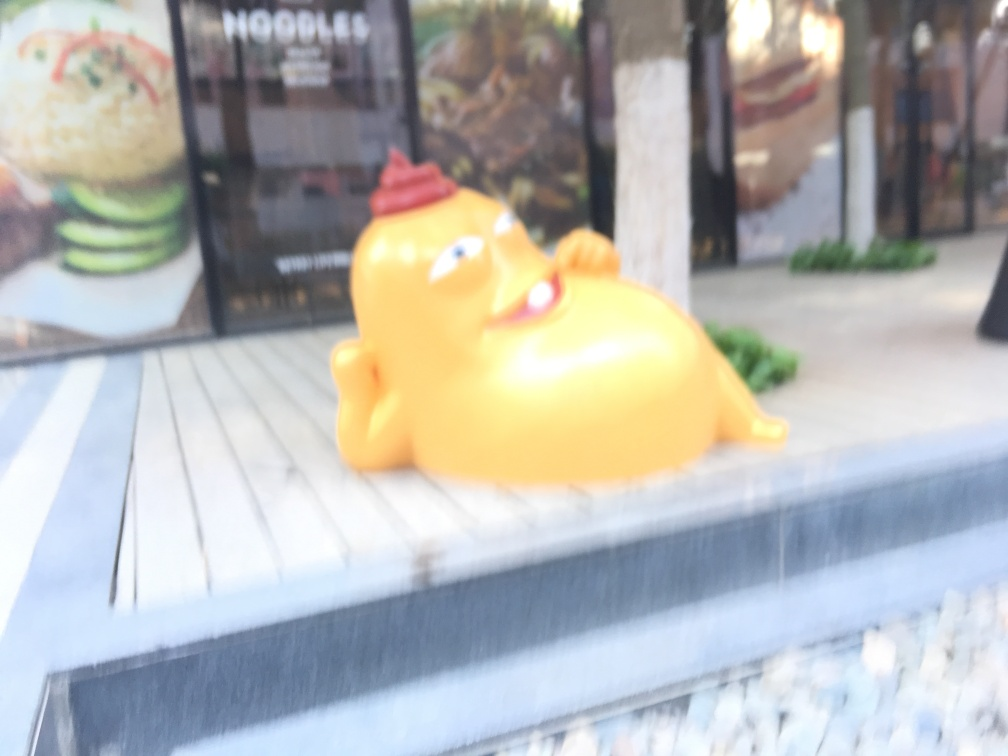What is the object in the foreground and what might it represent? The object in the foreground appears to be a stylized yellow figurine, possibly a rubber duck or a similar toy. Its exaggerated features and relaxed pose might represent leisure or convey a playful tone, often associated with such novelties. What is the context or setting of this image? The figurine is situated on a flat surface, which looks like an outdoor seating area of a restaurant or cafe, hinted by the presence of a menu poster in the background. It might be part of the establishment's decor to attract attention and impart a whimsical ambiance. 